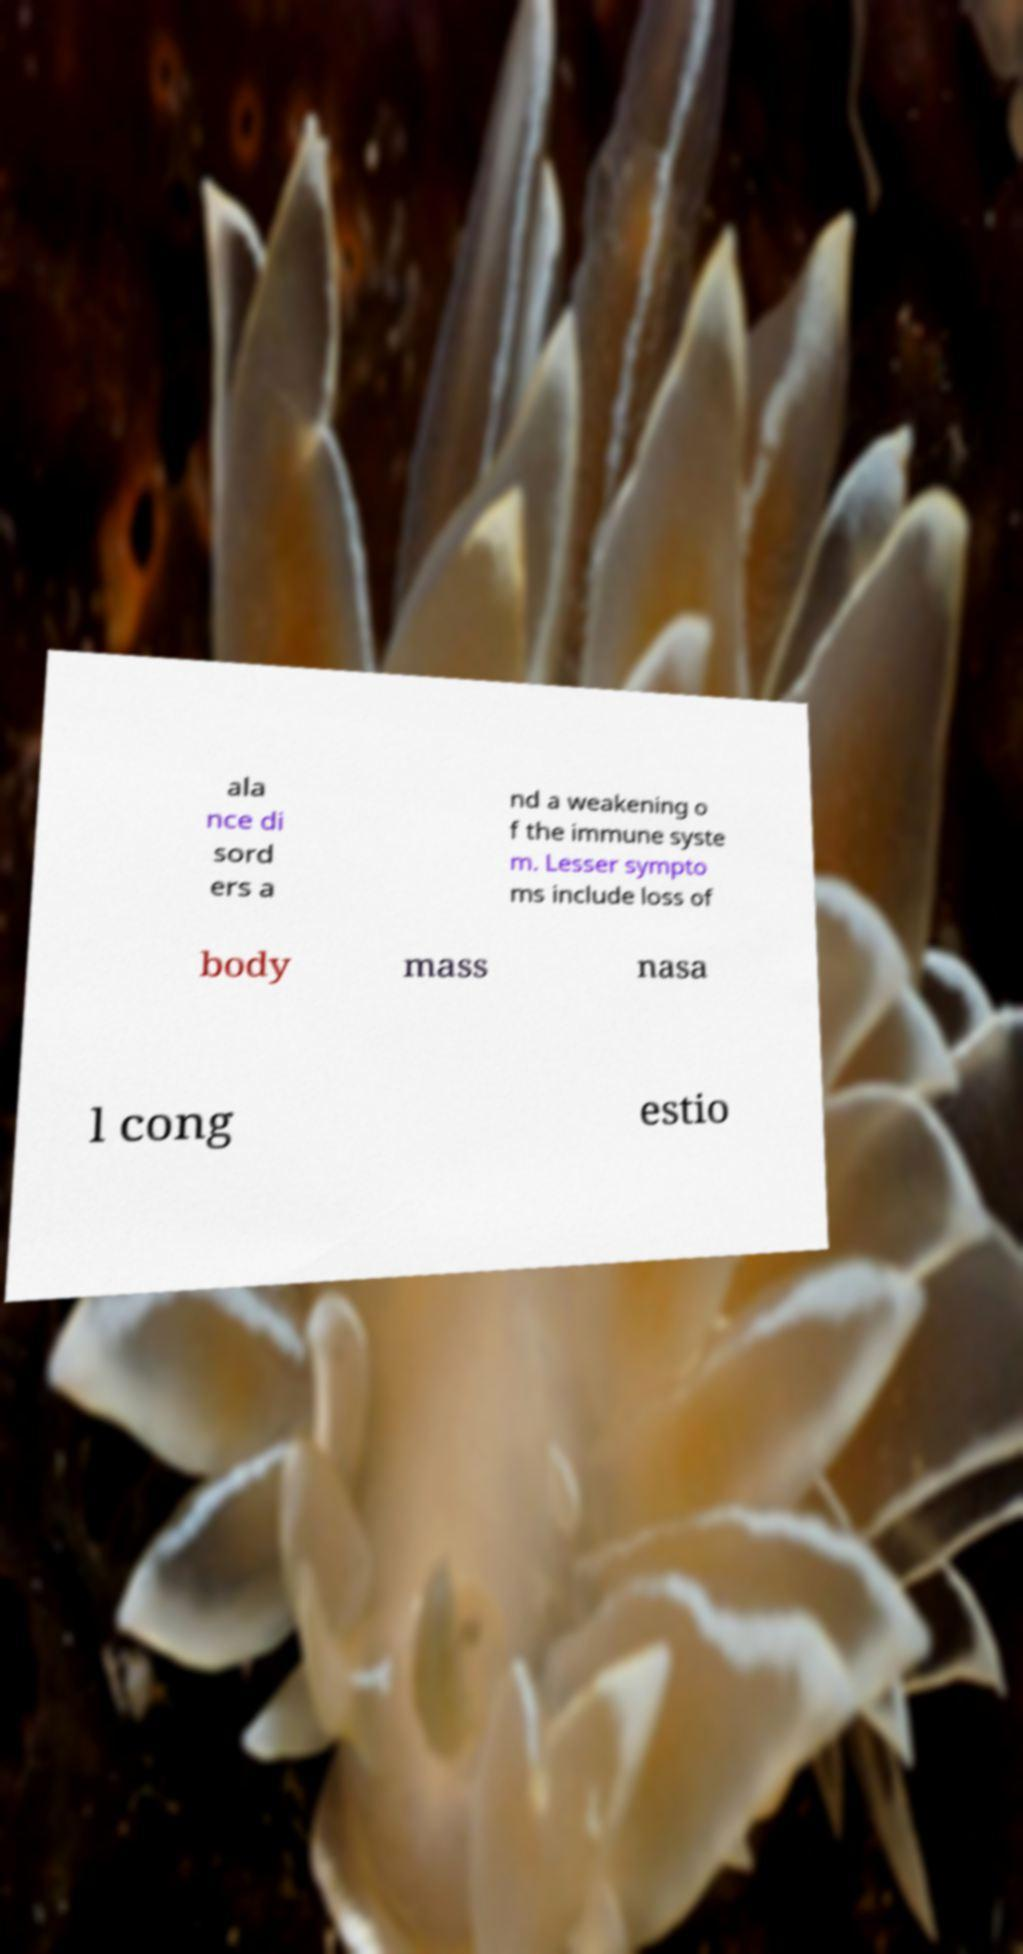Could you extract and type out the text from this image? ala nce di sord ers a nd a weakening o f the immune syste m. Lesser sympto ms include loss of body mass nasa l cong estio 